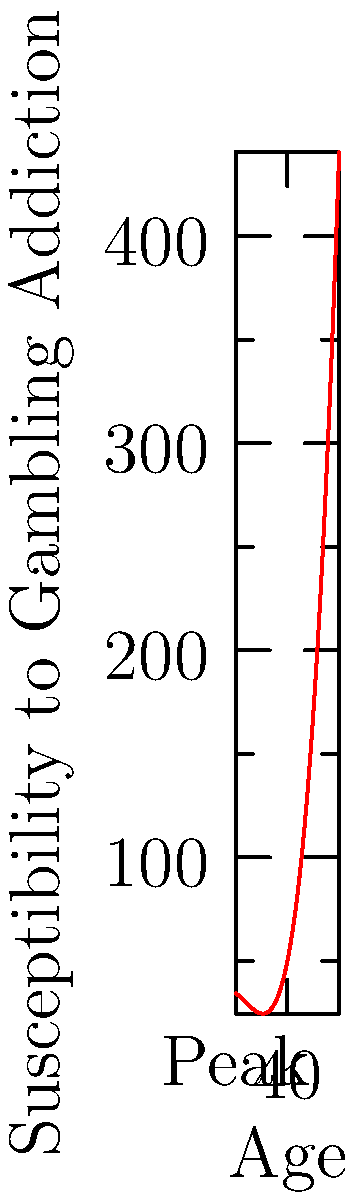The graph shows the relationship between age and susceptibility to gambling addiction using a polynomial regression curve. At approximately what age does the susceptibility to gambling addiction peak according to this model? To find the age at which susceptibility to gambling addiction peaks, we need to follow these steps:

1. The curve represents a polynomial function of degree 3 (cubic function).
2. The peak of the curve corresponds to the maximum point of the function.
3. To find the maximum point, we need to identify where the slope of the curve changes from positive to negative.
4. Visually inspecting the graph, we can see that the curve reaches its highest point around the middle of the x-axis.
5. The x-axis represents age, ranging from 15 to 65 years old.
6. The peak appears to be slightly to the left of the midpoint between 15 and 65.
7. The midpoint would be (15 + 65) / 2 = 40 years old.
8. The peak looks to be about 5 years before the midpoint.

Therefore, based on visual estimation from the graph, the susceptibility to gambling addiction peaks at approximately 35 years of age.
Answer: 35 years old 